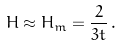<formula> <loc_0><loc_0><loc_500><loc_500>H \approx H _ { m } = \frac { 2 } { 3 t } \, .</formula> 